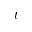Convert formula to latex. <formula><loc_0><loc_0><loc_500><loc_500>t</formula> 